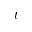Convert formula to latex. <formula><loc_0><loc_0><loc_500><loc_500>t</formula> 